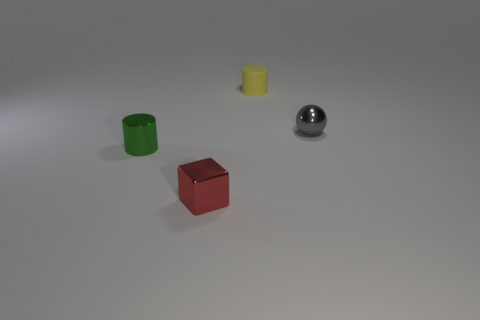Add 4 small metallic cylinders. How many objects exist? 8 Subtract all blocks. How many objects are left? 3 Add 2 red shiny objects. How many red shiny objects are left? 3 Add 1 tiny matte cylinders. How many tiny matte cylinders exist? 2 Subtract 0 brown balls. How many objects are left? 4 Subtract all big purple cylinders. Subtract all metal cubes. How many objects are left? 3 